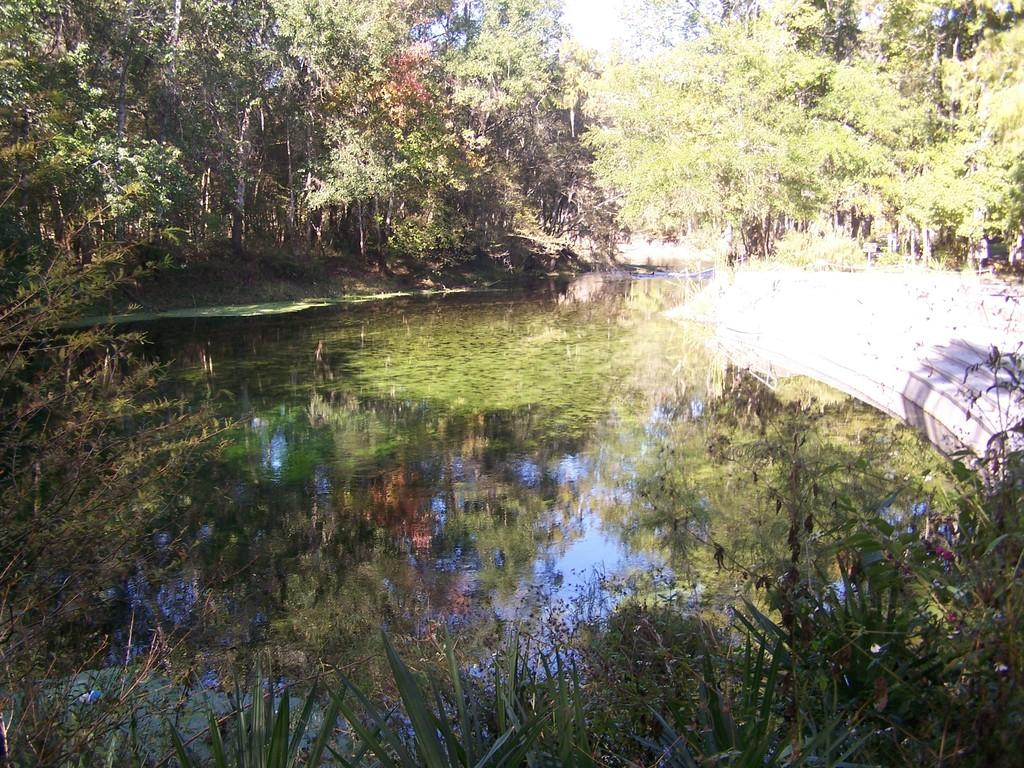What type of natural feature can be seen in the image? There is a water body in the image. What architectural feature is present in the image? There is a staircase in the image. What type of vegetation is visible in the image? There are plants and a group of trees in the image. What is visible in the background of the image? The sky is visible in the image. What type of soda is being served in the image? There is no soda present in the image; it features a water body, a staircase, plants, a group of trees, and the sky. 